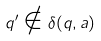<formula> <loc_0><loc_0><loc_500><loc_500>q ^ { \prime } \notin \delta ( q , a )</formula> 